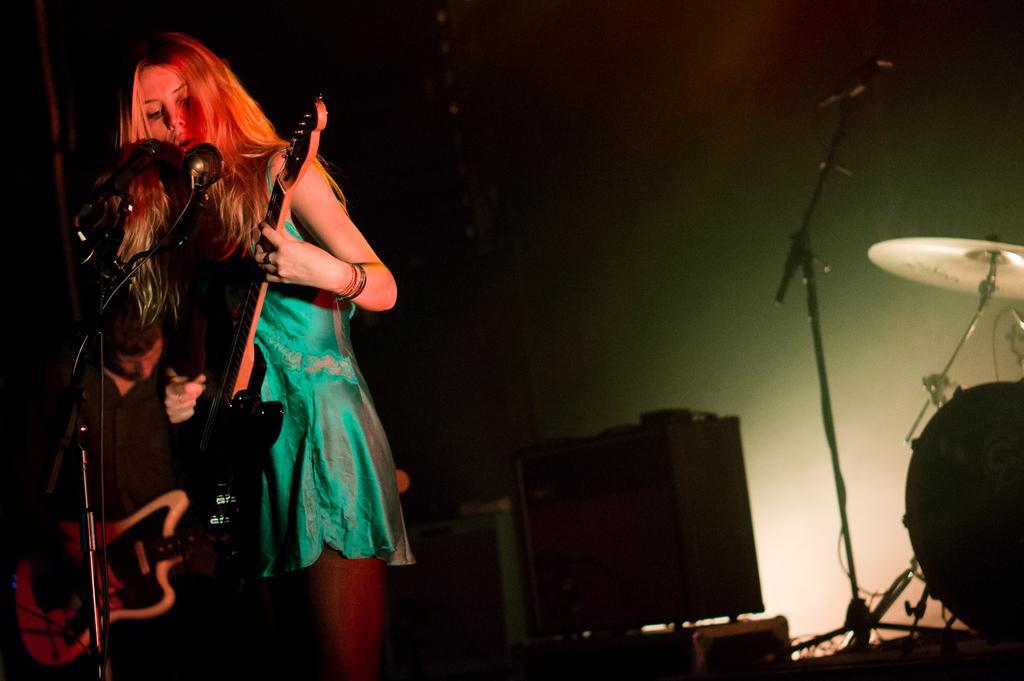How would you summarize this image in a sentence or two? A woman is standing at the left side of the image. She is singing and playing guitar. There is a mike stand before to her. Behind to her there is a person holding a guitar. At the right side there is a musical instrument, beside there is a mike stand. 